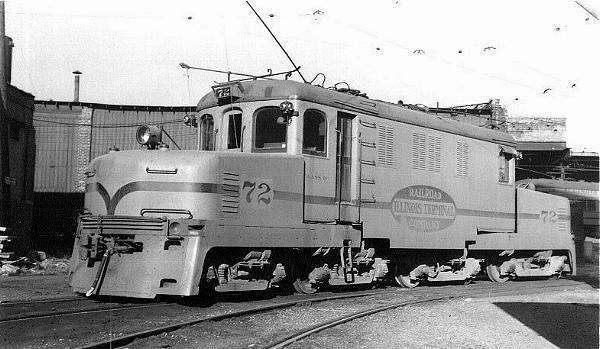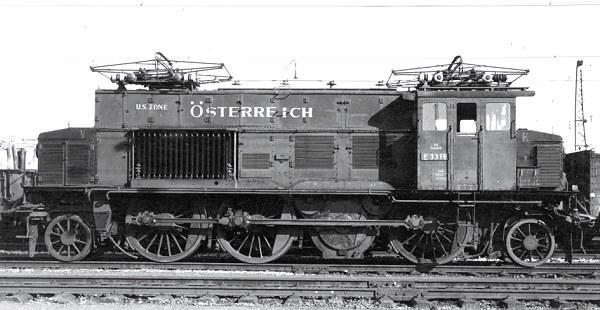The first image is the image on the left, the second image is the image on the right. For the images displayed, is the sentence "Two trains are both heading towards the left direction." factually correct? Answer yes or no. No. 